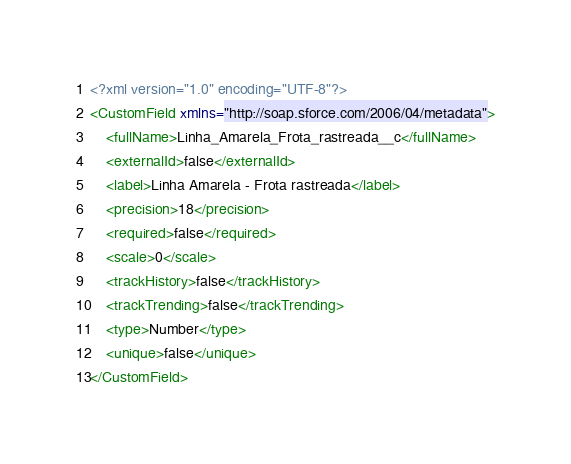<code> <loc_0><loc_0><loc_500><loc_500><_XML_><?xml version="1.0" encoding="UTF-8"?>
<CustomField xmlns="http://soap.sforce.com/2006/04/metadata">
    <fullName>Linha_Amarela_Frota_rastreada__c</fullName>
    <externalId>false</externalId>
    <label>Linha Amarela - Frota rastreada</label>
    <precision>18</precision>
    <required>false</required>
    <scale>0</scale>
    <trackHistory>false</trackHistory>
    <trackTrending>false</trackTrending>
    <type>Number</type>
    <unique>false</unique>
</CustomField>
</code> 